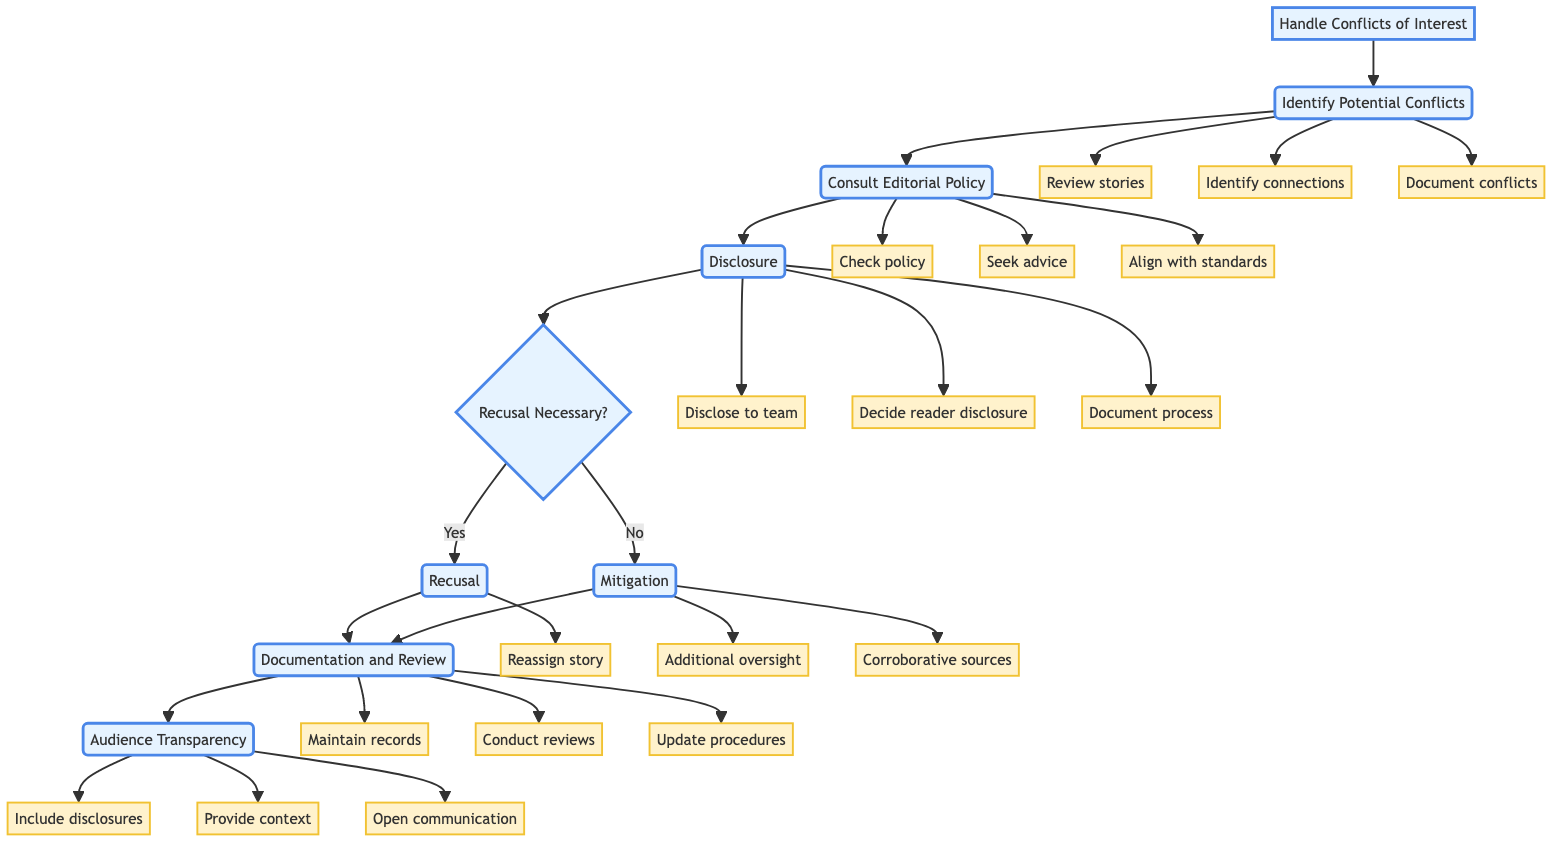What is the first stage in handling conflicts of interest? The diagram indicates the first stage as "Identify Potential Conflicts."
Answer: Identify Potential Conflicts How many stages are represented in this flowchart? There are six stages in the flowchart: Identify Potential Conflicts, Consult Editorial Policy, Disclosure, Recusal or Mitigation, Documentation and Review, Audience Transparency.
Answer: Six What action is taken after the "Disclosure" stage? After the Disclosure stage, the next step is to determine whether recusal is necessary by evaluating the situation which leads to "Recusal Necessary?"
Answer: Recusal Necessary? What is the action taken if recusal is deemed necessary? If recusal is necessary, the flowchart indicates that the story is reassigned to another journalist, specifically under the stage "Recusal."
Answer: Reassign story What document is referenced during the "Consult Editorial Policy" stage? The relevant document referred to during this stage is the publication's conflict of interest policy.
Answer: Conflict of interest policy How many actions are associated with the "Audience Transparency" stage? There are three actions associated with the Audience Transparency stage: Incorporate appropriate disclosures, Provide readers with context, and Maintain open communication.
Answer: Three What is the final stage in the conflict handling process? The final stage mentioned in the flowchart is "Audience Transparency."
Answer: Audience Transparency What occurs if mitigation strategies are applied instead of recusal? If mitigation strategies are applied, the diagram mentions adopting additional oversight and corroborative sources as part of the process.
Answer: Additional oversight, corroborative sources What is documented during the "Documentation and Review" stage? The stage indicates that all disclosures and mitigations should be maintained as a record, and includes periodic reviews of the conflict of interest policy.
Answer: Maintain a record of disclosures and mitigations 